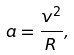Convert formula to latex. <formula><loc_0><loc_0><loc_500><loc_500>a = \frac { v ^ { 2 } } { R } ,</formula> 